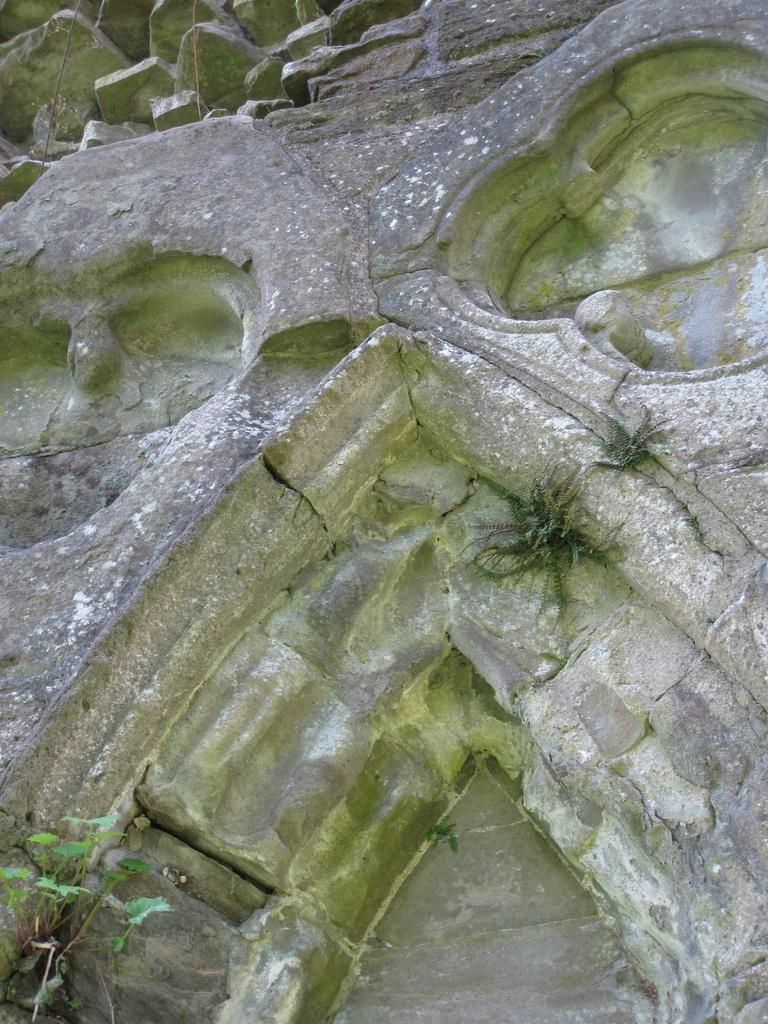What is the main structure in the image? There is a platform in the image. What type of vegetation is on the platform? Grass and small plants are visible on the platform. What other objects can be seen on the platform? Stones are observable at the top of the platform. What type of meal is being served in the room in the image? There is no room or meal present in the image; it features a platform with grass, small plants, and stones. 